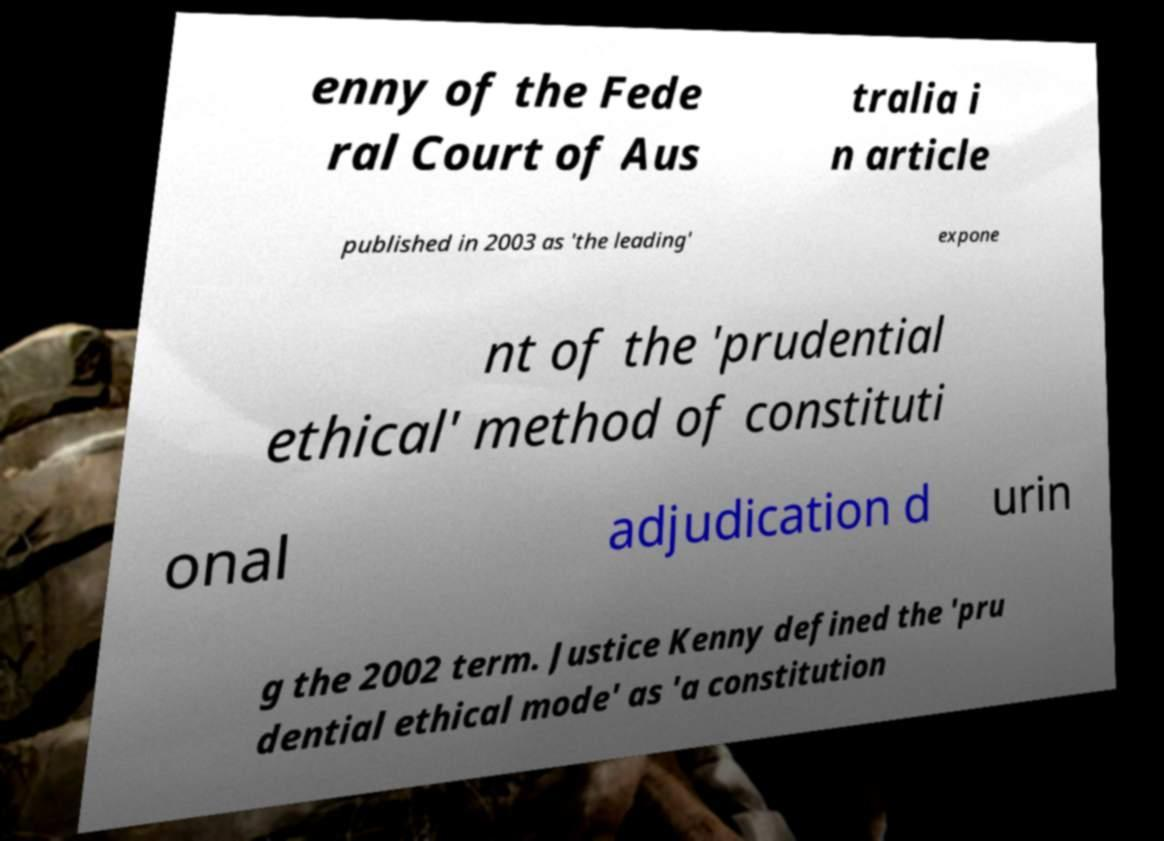Please identify and transcribe the text found in this image. enny of the Fede ral Court of Aus tralia i n article published in 2003 as 'the leading' expone nt of the 'prudential ethical' method of constituti onal adjudication d urin g the 2002 term. Justice Kenny defined the 'pru dential ethical mode' as 'a constitution 